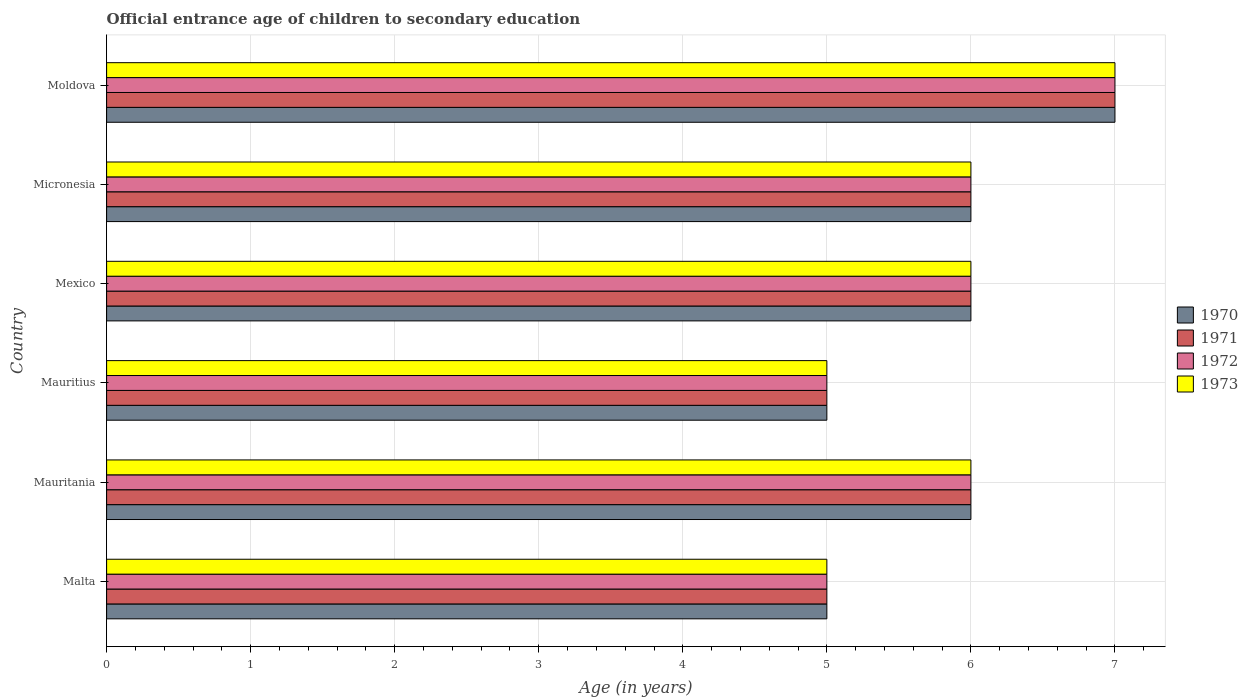Are the number of bars per tick equal to the number of legend labels?
Offer a terse response. Yes. Are the number of bars on each tick of the Y-axis equal?
Your answer should be very brief. Yes. How many bars are there on the 6th tick from the top?
Your response must be concise. 4. What is the label of the 3rd group of bars from the top?
Your answer should be compact. Mexico. In how many cases, is the number of bars for a given country not equal to the number of legend labels?
Offer a terse response. 0. What is the secondary school starting age of children in 1970 in Mexico?
Offer a very short reply. 6. Across all countries, what is the minimum secondary school starting age of children in 1972?
Make the answer very short. 5. In which country was the secondary school starting age of children in 1972 maximum?
Provide a short and direct response. Moldova. In which country was the secondary school starting age of children in 1970 minimum?
Offer a terse response. Malta. What is the difference between the secondary school starting age of children in 1973 in Mexico and that in Micronesia?
Provide a succinct answer. 0. What is the difference between the secondary school starting age of children in 1973 in Moldova and the secondary school starting age of children in 1970 in Micronesia?
Your response must be concise. 1. What is the average secondary school starting age of children in 1970 per country?
Your answer should be compact. 5.83. In how many countries, is the secondary school starting age of children in 1973 greater than 5 years?
Your answer should be compact. 4. What is the ratio of the secondary school starting age of children in 1971 in Mauritius to that in Mexico?
Provide a succinct answer. 0.83. Is the secondary school starting age of children in 1970 in Mauritania less than that in Micronesia?
Provide a short and direct response. No. Is the difference between the secondary school starting age of children in 1972 in Mauritania and Micronesia greater than the difference between the secondary school starting age of children in 1971 in Mauritania and Micronesia?
Offer a very short reply. No. Is the sum of the secondary school starting age of children in 1970 in Mauritius and Mexico greater than the maximum secondary school starting age of children in 1971 across all countries?
Ensure brevity in your answer.  Yes. What does the 1st bar from the top in Mexico represents?
Your answer should be very brief. 1973. Is it the case that in every country, the sum of the secondary school starting age of children in 1973 and secondary school starting age of children in 1972 is greater than the secondary school starting age of children in 1970?
Your response must be concise. Yes. Are all the bars in the graph horizontal?
Ensure brevity in your answer.  Yes. How many countries are there in the graph?
Offer a terse response. 6. Does the graph contain any zero values?
Provide a succinct answer. No. Does the graph contain grids?
Offer a terse response. Yes. How many legend labels are there?
Provide a succinct answer. 4. What is the title of the graph?
Make the answer very short. Official entrance age of children to secondary education. What is the label or title of the X-axis?
Your response must be concise. Age (in years). What is the Age (in years) of 1970 in Malta?
Make the answer very short. 5. What is the Age (in years) in 1972 in Mauritania?
Ensure brevity in your answer.  6. What is the Age (in years) of 1973 in Mauritania?
Provide a short and direct response. 6. What is the Age (in years) in 1971 in Mauritius?
Ensure brevity in your answer.  5. What is the Age (in years) in 1972 in Mauritius?
Give a very brief answer. 5. What is the Age (in years) in 1973 in Mauritius?
Ensure brevity in your answer.  5. What is the Age (in years) of 1971 in Mexico?
Keep it short and to the point. 6. What is the Age (in years) in 1973 in Mexico?
Your response must be concise. 6. What is the Age (in years) of 1972 in Micronesia?
Your response must be concise. 6. What is the Age (in years) in 1973 in Micronesia?
Your answer should be compact. 6. What is the Age (in years) in 1972 in Moldova?
Offer a terse response. 7. Across all countries, what is the maximum Age (in years) in 1971?
Your answer should be compact. 7. Across all countries, what is the maximum Age (in years) of 1972?
Your answer should be compact. 7. Across all countries, what is the minimum Age (in years) of 1970?
Keep it short and to the point. 5. Across all countries, what is the minimum Age (in years) of 1971?
Provide a short and direct response. 5. Across all countries, what is the minimum Age (in years) in 1972?
Make the answer very short. 5. What is the total Age (in years) of 1970 in the graph?
Make the answer very short. 35. What is the total Age (in years) of 1972 in the graph?
Your response must be concise. 35. What is the difference between the Age (in years) of 1970 in Malta and that in Mauritania?
Provide a succinct answer. -1. What is the difference between the Age (in years) in 1973 in Malta and that in Mauritania?
Your answer should be very brief. -1. What is the difference between the Age (in years) of 1971 in Malta and that in Mauritius?
Your response must be concise. 0. What is the difference between the Age (in years) in 1972 in Malta and that in Mauritius?
Your response must be concise. 0. What is the difference between the Age (in years) in 1973 in Malta and that in Mauritius?
Your answer should be compact. 0. What is the difference between the Age (in years) of 1970 in Malta and that in Mexico?
Give a very brief answer. -1. What is the difference between the Age (in years) of 1971 in Malta and that in Mexico?
Give a very brief answer. -1. What is the difference between the Age (in years) of 1972 in Malta and that in Mexico?
Offer a very short reply. -1. What is the difference between the Age (in years) of 1973 in Malta and that in Mexico?
Provide a short and direct response. -1. What is the difference between the Age (in years) of 1970 in Malta and that in Micronesia?
Offer a terse response. -1. What is the difference between the Age (in years) of 1972 in Malta and that in Micronesia?
Keep it short and to the point. -1. What is the difference between the Age (in years) of 1973 in Malta and that in Micronesia?
Offer a terse response. -1. What is the difference between the Age (in years) of 1970 in Malta and that in Moldova?
Make the answer very short. -2. What is the difference between the Age (in years) of 1973 in Malta and that in Moldova?
Give a very brief answer. -2. What is the difference between the Age (in years) of 1971 in Mauritania and that in Mauritius?
Your answer should be very brief. 1. What is the difference between the Age (in years) in 1972 in Mauritania and that in Mauritius?
Offer a terse response. 1. What is the difference between the Age (in years) of 1973 in Mauritania and that in Mauritius?
Offer a very short reply. 1. What is the difference between the Age (in years) in 1970 in Mauritania and that in Mexico?
Make the answer very short. 0. What is the difference between the Age (in years) in 1972 in Mauritania and that in Mexico?
Provide a short and direct response. 0. What is the difference between the Age (in years) in 1972 in Mauritania and that in Micronesia?
Your answer should be compact. 0. What is the difference between the Age (in years) of 1970 in Mauritania and that in Moldova?
Provide a succinct answer. -1. What is the difference between the Age (in years) of 1973 in Mauritania and that in Moldova?
Provide a succinct answer. -1. What is the difference between the Age (in years) in 1971 in Mauritius and that in Mexico?
Make the answer very short. -1. What is the difference between the Age (in years) in 1972 in Mauritius and that in Mexico?
Provide a short and direct response. -1. What is the difference between the Age (in years) in 1970 in Mauritius and that in Micronesia?
Your answer should be compact. -1. What is the difference between the Age (in years) in 1971 in Mauritius and that in Micronesia?
Ensure brevity in your answer.  -1. What is the difference between the Age (in years) in 1972 in Mauritius and that in Micronesia?
Provide a short and direct response. -1. What is the difference between the Age (in years) of 1970 in Mauritius and that in Moldova?
Provide a succinct answer. -2. What is the difference between the Age (in years) of 1971 in Mauritius and that in Moldova?
Offer a very short reply. -2. What is the difference between the Age (in years) of 1973 in Mauritius and that in Moldova?
Your answer should be very brief. -2. What is the difference between the Age (in years) of 1970 in Mexico and that in Micronesia?
Ensure brevity in your answer.  0. What is the difference between the Age (in years) in 1972 in Mexico and that in Micronesia?
Make the answer very short. 0. What is the difference between the Age (in years) of 1972 in Mexico and that in Moldova?
Your answer should be very brief. -1. What is the difference between the Age (in years) in 1973 in Mexico and that in Moldova?
Provide a succinct answer. -1. What is the difference between the Age (in years) of 1970 in Micronesia and that in Moldova?
Your response must be concise. -1. What is the difference between the Age (in years) in 1971 in Micronesia and that in Moldova?
Offer a very short reply. -1. What is the difference between the Age (in years) in 1972 in Micronesia and that in Moldova?
Provide a succinct answer. -1. What is the difference between the Age (in years) of 1971 in Malta and the Age (in years) of 1973 in Mauritania?
Provide a short and direct response. -1. What is the difference between the Age (in years) of 1972 in Malta and the Age (in years) of 1973 in Mauritania?
Make the answer very short. -1. What is the difference between the Age (in years) of 1970 in Malta and the Age (in years) of 1972 in Mauritius?
Ensure brevity in your answer.  0. What is the difference between the Age (in years) of 1971 in Malta and the Age (in years) of 1972 in Mauritius?
Give a very brief answer. 0. What is the difference between the Age (in years) in 1971 in Malta and the Age (in years) in 1973 in Mauritius?
Keep it short and to the point. 0. What is the difference between the Age (in years) of 1972 in Malta and the Age (in years) of 1973 in Mauritius?
Offer a very short reply. 0. What is the difference between the Age (in years) of 1970 in Malta and the Age (in years) of 1973 in Mexico?
Keep it short and to the point. -1. What is the difference between the Age (in years) in 1971 in Malta and the Age (in years) in 1972 in Mexico?
Ensure brevity in your answer.  -1. What is the difference between the Age (in years) of 1971 in Malta and the Age (in years) of 1973 in Mexico?
Ensure brevity in your answer.  -1. What is the difference between the Age (in years) in 1972 in Malta and the Age (in years) in 1973 in Mexico?
Keep it short and to the point. -1. What is the difference between the Age (in years) of 1970 in Malta and the Age (in years) of 1971 in Micronesia?
Make the answer very short. -1. What is the difference between the Age (in years) in 1970 in Malta and the Age (in years) in 1972 in Micronesia?
Make the answer very short. -1. What is the difference between the Age (in years) of 1971 in Malta and the Age (in years) of 1973 in Micronesia?
Give a very brief answer. -1. What is the difference between the Age (in years) in 1972 in Malta and the Age (in years) in 1973 in Micronesia?
Give a very brief answer. -1. What is the difference between the Age (in years) in 1971 in Malta and the Age (in years) in 1973 in Moldova?
Provide a succinct answer. -2. What is the difference between the Age (in years) of 1972 in Malta and the Age (in years) of 1973 in Moldova?
Keep it short and to the point. -2. What is the difference between the Age (in years) of 1970 in Mauritania and the Age (in years) of 1971 in Mauritius?
Keep it short and to the point. 1. What is the difference between the Age (in years) in 1970 in Mauritania and the Age (in years) in 1972 in Mauritius?
Your answer should be compact. 1. What is the difference between the Age (in years) in 1971 in Mauritania and the Age (in years) in 1973 in Mexico?
Ensure brevity in your answer.  0. What is the difference between the Age (in years) of 1972 in Mauritania and the Age (in years) of 1973 in Mexico?
Offer a terse response. 0. What is the difference between the Age (in years) in 1970 in Mauritania and the Age (in years) in 1971 in Micronesia?
Provide a succinct answer. 0. What is the difference between the Age (in years) in 1971 in Mauritania and the Age (in years) in 1972 in Micronesia?
Offer a terse response. 0. What is the difference between the Age (in years) in 1971 in Mauritania and the Age (in years) in 1973 in Micronesia?
Provide a succinct answer. 0. What is the difference between the Age (in years) in 1972 in Mauritania and the Age (in years) in 1973 in Micronesia?
Your response must be concise. 0. What is the difference between the Age (in years) in 1970 in Mauritania and the Age (in years) in 1972 in Moldova?
Provide a succinct answer. -1. What is the difference between the Age (in years) in 1971 in Mauritania and the Age (in years) in 1972 in Moldova?
Ensure brevity in your answer.  -1. What is the difference between the Age (in years) of 1971 in Mauritania and the Age (in years) of 1973 in Moldova?
Your response must be concise. -1. What is the difference between the Age (in years) of 1970 in Mauritius and the Age (in years) of 1971 in Mexico?
Provide a succinct answer. -1. What is the difference between the Age (in years) of 1970 in Mauritius and the Age (in years) of 1973 in Mexico?
Provide a short and direct response. -1. What is the difference between the Age (in years) of 1971 in Mauritius and the Age (in years) of 1973 in Mexico?
Offer a terse response. -1. What is the difference between the Age (in years) of 1970 in Mauritius and the Age (in years) of 1971 in Micronesia?
Give a very brief answer. -1. What is the difference between the Age (in years) in 1971 in Mauritius and the Age (in years) in 1972 in Micronesia?
Keep it short and to the point. -1. What is the difference between the Age (in years) of 1972 in Mauritius and the Age (in years) of 1973 in Micronesia?
Provide a short and direct response. -1. What is the difference between the Age (in years) of 1970 in Mauritius and the Age (in years) of 1971 in Moldova?
Ensure brevity in your answer.  -2. What is the difference between the Age (in years) in 1970 in Mauritius and the Age (in years) in 1972 in Moldova?
Offer a terse response. -2. What is the difference between the Age (in years) of 1971 in Mauritius and the Age (in years) of 1973 in Moldova?
Your answer should be compact. -2. What is the difference between the Age (in years) in 1972 in Mauritius and the Age (in years) in 1973 in Moldova?
Keep it short and to the point. -2. What is the difference between the Age (in years) in 1970 in Mexico and the Age (in years) in 1971 in Micronesia?
Ensure brevity in your answer.  0. What is the difference between the Age (in years) in 1970 in Mexico and the Age (in years) in 1972 in Micronesia?
Ensure brevity in your answer.  0. What is the difference between the Age (in years) in 1970 in Mexico and the Age (in years) in 1973 in Micronesia?
Your answer should be compact. 0. What is the difference between the Age (in years) of 1970 in Mexico and the Age (in years) of 1973 in Moldova?
Provide a short and direct response. -1. What is the difference between the Age (in years) in 1971 in Mexico and the Age (in years) in 1972 in Moldova?
Make the answer very short. -1. What is the difference between the Age (in years) of 1970 in Micronesia and the Age (in years) of 1971 in Moldova?
Keep it short and to the point. -1. What is the difference between the Age (in years) in 1970 in Micronesia and the Age (in years) in 1972 in Moldova?
Ensure brevity in your answer.  -1. What is the difference between the Age (in years) in 1970 in Micronesia and the Age (in years) in 1973 in Moldova?
Your answer should be very brief. -1. What is the difference between the Age (in years) in 1972 in Micronesia and the Age (in years) in 1973 in Moldova?
Ensure brevity in your answer.  -1. What is the average Age (in years) in 1970 per country?
Offer a very short reply. 5.83. What is the average Age (in years) in 1971 per country?
Keep it short and to the point. 5.83. What is the average Age (in years) in 1972 per country?
Keep it short and to the point. 5.83. What is the average Age (in years) in 1973 per country?
Keep it short and to the point. 5.83. What is the difference between the Age (in years) in 1970 and Age (in years) in 1971 in Malta?
Give a very brief answer. 0. What is the difference between the Age (in years) in 1970 and Age (in years) in 1973 in Malta?
Offer a very short reply. 0. What is the difference between the Age (in years) in 1972 and Age (in years) in 1973 in Malta?
Ensure brevity in your answer.  0. What is the difference between the Age (in years) in 1970 and Age (in years) in 1973 in Mauritania?
Provide a short and direct response. 0. What is the difference between the Age (in years) in 1970 and Age (in years) in 1972 in Mauritius?
Your answer should be compact. 0. What is the difference between the Age (in years) in 1971 and Age (in years) in 1972 in Mauritius?
Offer a terse response. 0. What is the difference between the Age (in years) of 1970 and Age (in years) of 1972 in Mexico?
Your answer should be compact. 0. What is the difference between the Age (in years) in 1971 and Age (in years) in 1972 in Mexico?
Offer a terse response. 0. What is the difference between the Age (in years) of 1971 and Age (in years) of 1973 in Mexico?
Provide a short and direct response. 0. What is the difference between the Age (in years) of 1970 and Age (in years) of 1971 in Micronesia?
Make the answer very short. 0. What is the difference between the Age (in years) of 1970 and Age (in years) of 1973 in Micronesia?
Your response must be concise. 0. What is the difference between the Age (in years) in 1971 and Age (in years) in 1972 in Micronesia?
Your answer should be very brief. 0. What is the difference between the Age (in years) of 1970 and Age (in years) of 1971 in Moldova?
Offer a terse response. 0. What is the difference between the Age (in years) of 1970 and Age (in years) of 1972 in Moldova?
Your response must be concise. 0. What is the difference between the Age (in years) of 1970 and Age (in years) of 1973 in Moldova?
Provide a short and direct response. 0. What is the difference between the Age (in years) in 1971 and Age (in years) in 1973 in Moldova?
Make the answer very short. 0. What is the difference between the Age (in years) in 1972 and Age (in years) in 1973 in Moldova?
Provide a succinct answer. 0. What is the ratio of the Age (in years) of 1972 in Malta to that in Mauritania?
Your response must be concise. 0.83. What is the ratio of the Age (in years) in 1973 in Malta to that in Mauritania?
Offer a terse response. 0.83. What is the ratio of the Age (in years) in 1971 in Malta to that in Mauritius?
Your response must be concise. 1. What is the ratio of the Age (in years) in 1972 in Malta to that in Mexico?
Offer a terse response. 0.83. What is the ratio of the Age (in years) of 1970 in Malta to that in Moldova?
Your response must be concise. 0.71. What is the ratio of the Age (in years) in 1973 in Malta to that in Moldova?
Ensure brevity in your answer.  0.71. What is the ratio of the Age (in years) in 1973 in Mauritania to that in Mauritius?
Provide a succinct answer. 1.2. What is the ratio of the Age (in years) in 1970 in Mauritania to that in Mexico?
Ensure brevity in your answer.  1. What is the ratio of the Age (in years) in 1970 in Mauritania to that in Micronesia?
Provide a short and direct response. 1. What is the ratio of the Age (in years) in 1970 in Mauritania to that in Moldova?
Make the answer very short. 0.86. What is the ratio of the Age (in years) in 1972 in Mauritania to that in Moldova?
Your answer should be compact. 0.86. What is the ratio of the Age (in years) of 1972 in Mauritius to that in Mexico?
Ensure brevity in your answer.  0.83. What is the ratio of the Age (in years) of 1970 in Mauritius to that in Micronesia?
Your answer should be compact. 0.83. What is the ratio of the Age (in years) of 1971 in Mauritius to that in Micronesia?
Keep it short and to the point. 0.83. What is the ratio of the Age (in years) of 1972 in Mauritius to that in Micronesia?
Provide a short and direct response. 0.83. What is the ratio of the Age (in years) of 1970 in Mauritius to that in Moldova?
Ensure brevity in your answer.  0.71. What is the ratio of the Age (in years) of 1971 in Mauritius to that in Moldova?
Make the answer very short. 0.71. What is the ratio of the Age (in years) in 1970 in Mexico to that in Micronesia?
Provide a succinct answer. 1. What is the ratio of the Age (in years) in 1972 in Mexico to that in Micronesia?
Provide a succinct answer. 1. What is the ratio of the Age (in years) of 1973 in Mexico to that in Micronesia?
Offer a very short reply. 1. What is the ratio of the Age (in years) in 1970 in Mexico to that in Moldova?
Give a very brief answer. 0.86. What is the ratio of the Age (in years) of 1971 in Mexico to that in Moldova?
Offer a terse response. 0.86. What is the ratio of the Age (in years) in 1973 in Mexico to that in Moldova?
Provide a short and direct response. 0.86. What is the ratio of the Age (in years) of 1970 in Micronesia to that in Moldova?
Offer a terse response. 0.86. What is the ratio of the Age (in years) of 1973 in Micronesia to that in Moldova?
Ensure brevity in your answer.  0.86. What is the difference between the highest and the second highest Age (in years) in 1970?
Give a very brief answer. 1. What is the difference between the highest and the second highest Age (in years) of 1972?
Your answer should be very brief. 1. What is the difference between the highest and the lowest Age (in years) in 1973?
Provide a succinct answer. 2. 